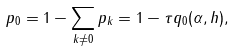Convert formula to latex. <formula><loc_0><loc_0><loc_500><loc_500>p _ { 0 } = 1 - \sum _ { k \neq 0 } p _ { k } = 1 - \tau q _ { 0 } ( \alpha , h ) ,</formula> 